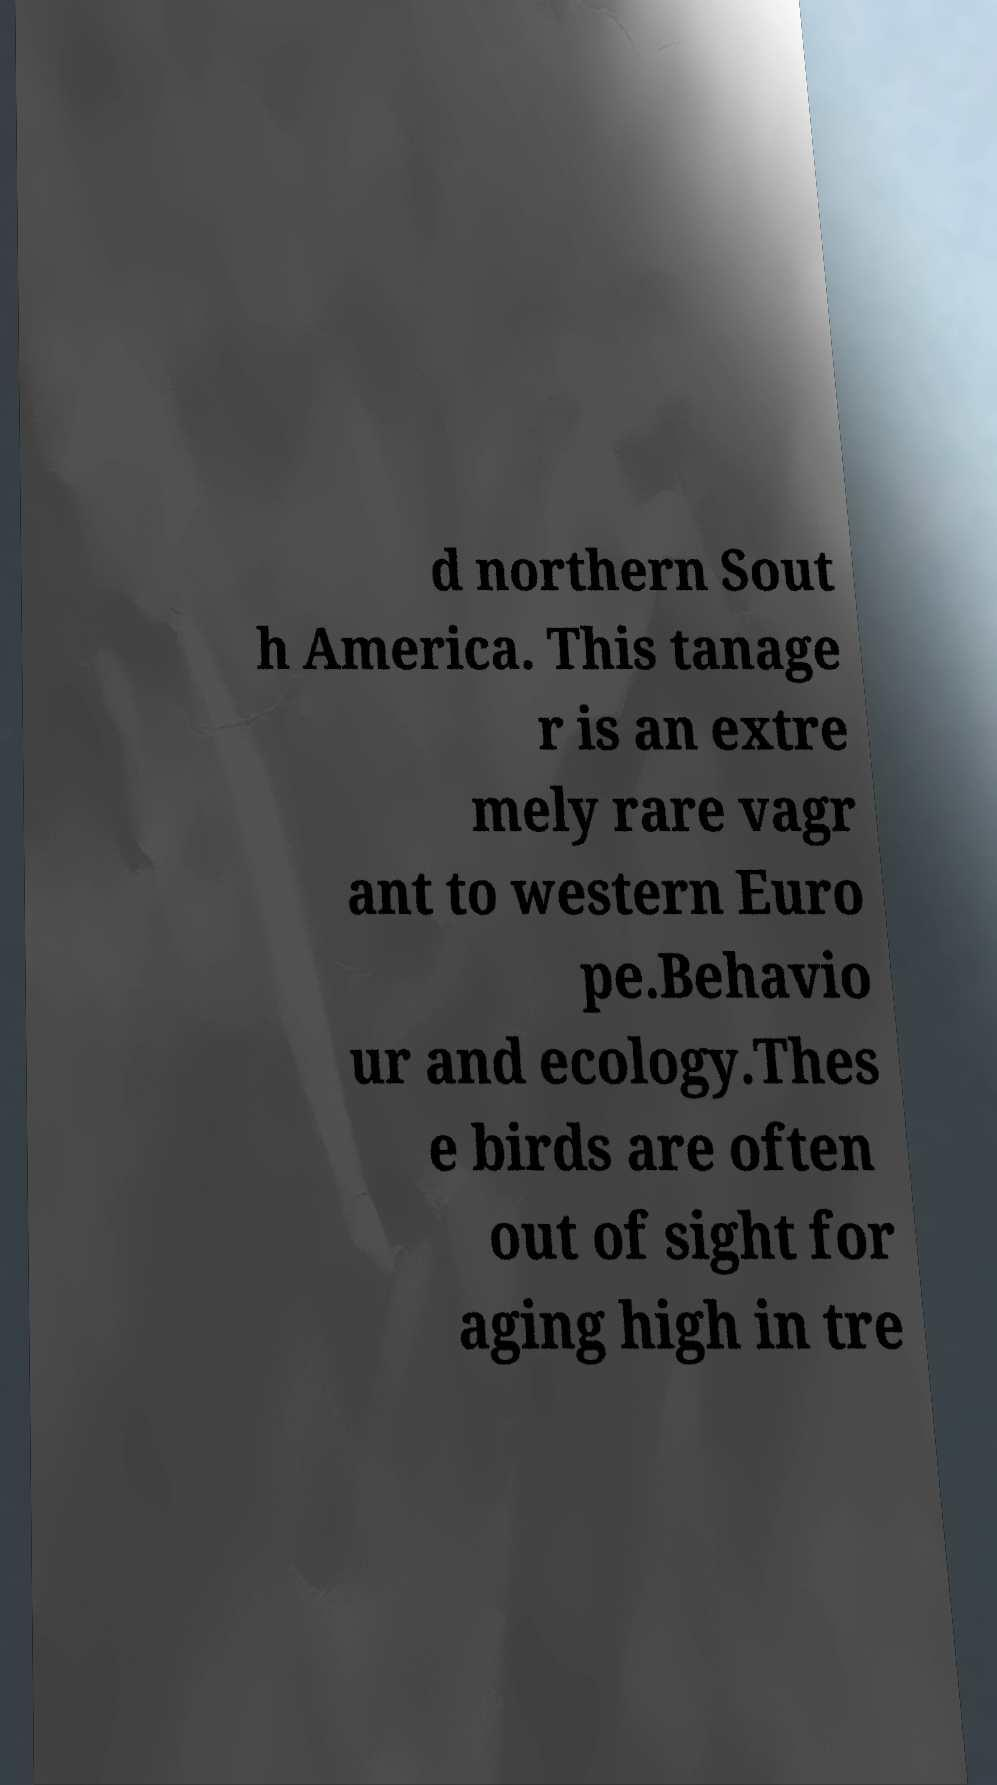What messages or text are displayed in this image? I need them in a readable, typed format. d northern Sout h America. This tanage r is an extre mely rare vagr ant to western Euro pe.Behavio ur and ecology.Thes e birds are often out of sight for aging high in tre 